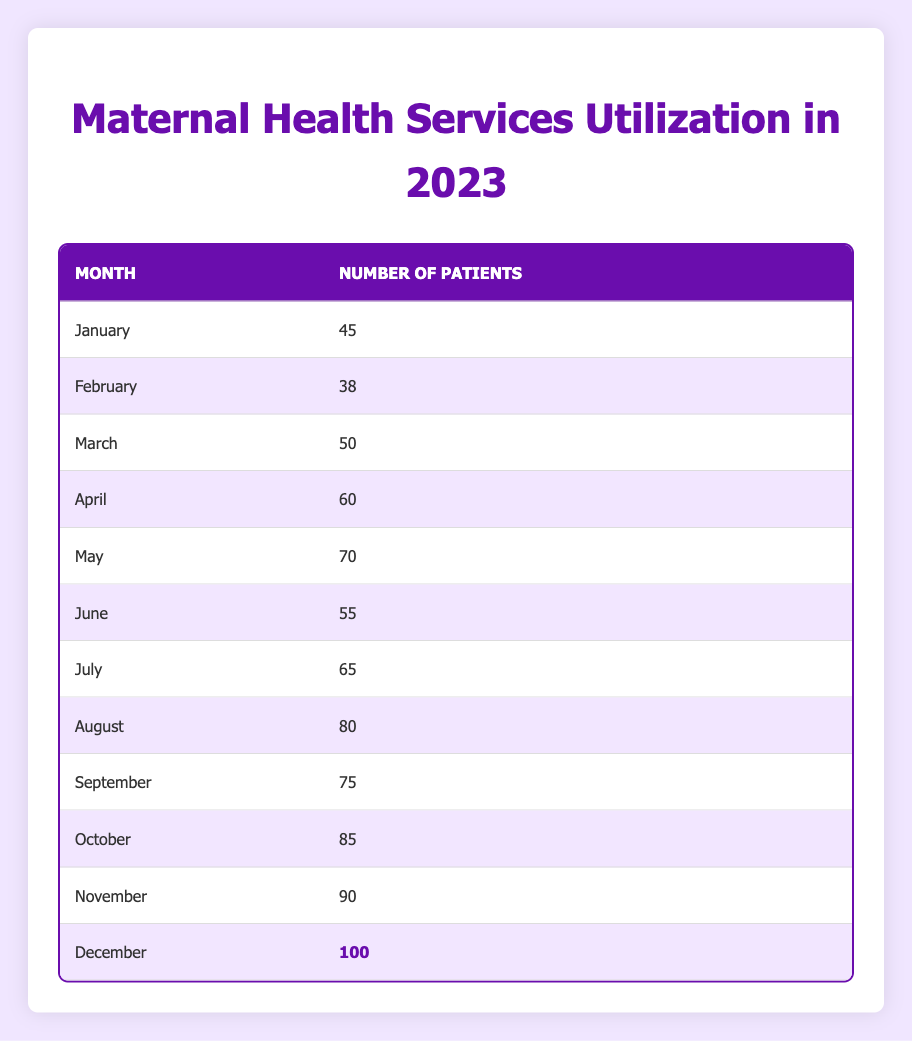What was the highest number of patients utilizing maternal health services in 2023? The highest number of patients is found by looking at the "Number of Patients" column. Scanning through, December has the highest count, which is 100.
Answer: 100 In which month did the maternal health services have the lowest number of patients? By examining the "Number of Patients" column, February has the smallest number, which is 38.
Answer: February What was the total number of patients who utilized maternal health services from January to March? To find the total, sum the patients from January (45), February (38), and March (50), which equals 45 + 38 + 50 = 133.
Answer: 133 Is it true that the number of patients increased every month throughout the year? Looking through the "Number of Patients" column, there are some increases but not every month reflects this. For example, February (38) is less than January (45). Thus, the statement is false.
Answer: No What is the average number of patients utilizing maternal health services from April to September? First, sum the number of patients from April (60), May (70), June (55), July (65), August (80), and September (75) to get 60 + 70 + 55 + 65 + 80 + 75 = 405. There are 6 months, so to find the average, divide the total by 6, giving us 405 / 6 = 67.5.
Answer: 67.5 What was the difference in the number of patients between the month with the highest and the month with the lowest utilization? The highest month is December with 100 patients and the lowest is February with 38 patients. To find the difference, subtract the lowest from the highest: 100 - 38 = 62.
Answer: 62 How many patients utilized maternal health services in October and November combined? To find this, add the number of patients from October (85) and November (90): 85 + 90 = 175.
Answer: 175 Which month showed a decline in the number of patients when compared to the previous month? By reviewing the comparison month-to-month, June (55) is lower than May (70), indicating a decline.
Answer: June 